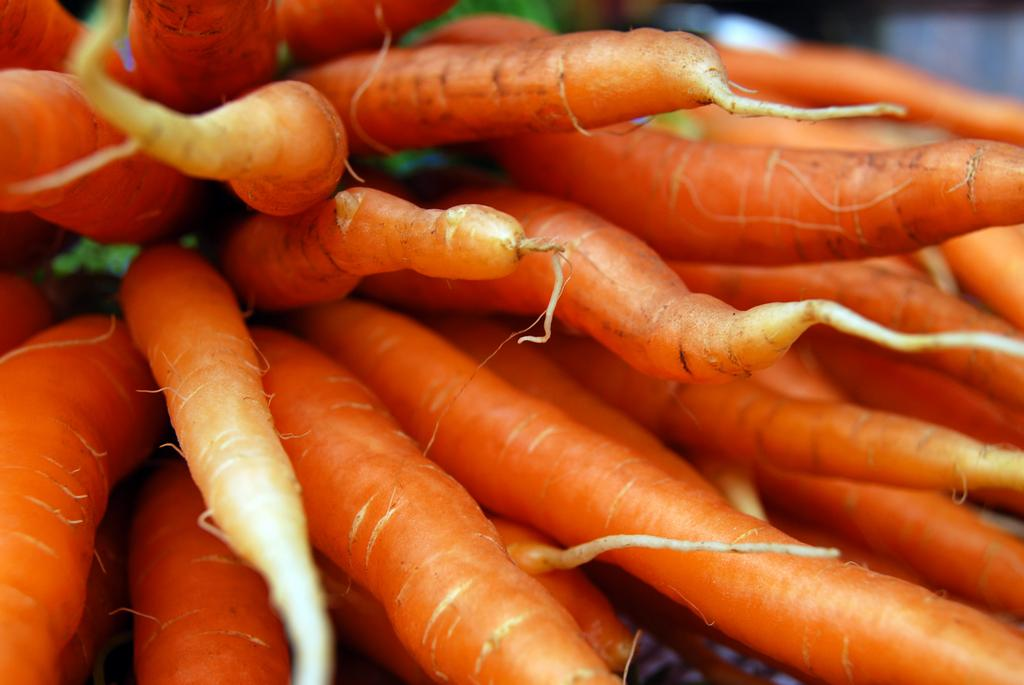What type of vegetable is present in the image? There are carrots in the image. What color is the eggnog in the image? There is no eggnog present in the image; it only contains carrots. 